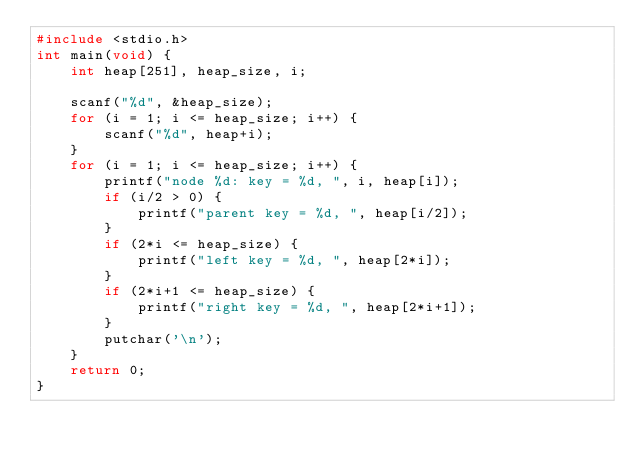<code> <loc_0><loc_0><loc_500><loc_500><_C_>#include <stdio.h>
int main(void) {
	int heap[251], heap_size, i;

	scanf("%d", &heap_size);
	for (i = 1; i <= heap_size; i++) {
		scanf("%d", heap+i);
	}
	for (i = 1; i <= heap_size; i++) {
		printf("node %d: key = %d, ", i, heap[i]);
		if (i/2 > 0) {
			printf("parent key = %d, ", heap[i/2]);
		}
		if (2*i <= heap_size) {
			printf("left key = %d, ", heap[2*i]);
		}
		if (2*i+1 <= heap_size) {
			printf("right key = %d, ", heap[2*i+1]);
		}
		putchar('\n');
	}
	return 0;
}
</code> 